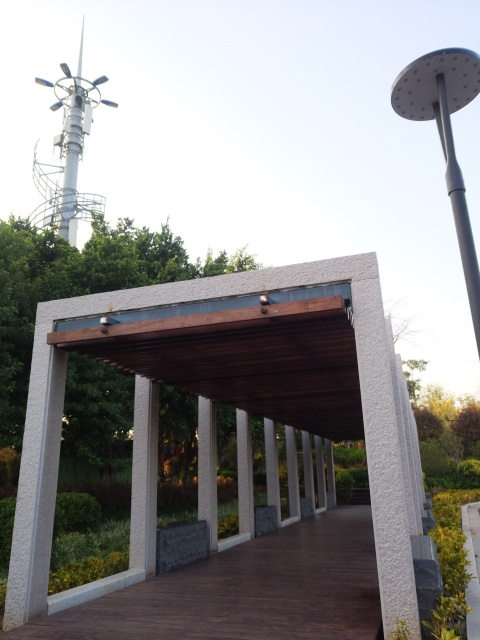Are there any unique features in this image that stand out to you? One interesting feature is the modern sculpture-like installation visible in the background. It appears to be some type of technological or artistic installation, possibly related to telecommunications due to its resemblance to an antenna. Its juxtaposition against the natural elements of the park creates a contrast between technology and nature, which is an intriguing aspect of this image. 